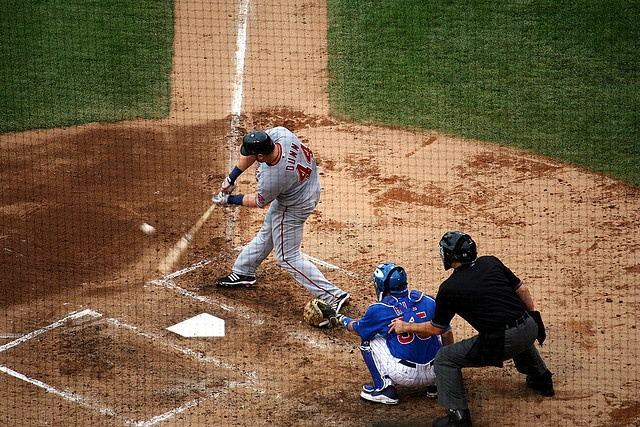Describe the objects in this image and their specific colors. I can see people in darkgreen, black, maroon, gray, and tan tones, people in darkgreen, gray, darkgray, black, and lightgray tones, people in darkgreen, navy, black, lavender, and darkblue tones, baseball bat in darkgreen, gray, tan, and brown tones, and baseball glove in darkgreen, black, maroon, and tan tones in this image. 